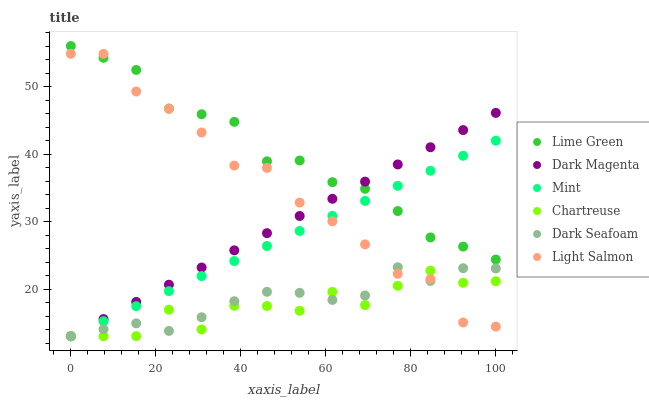Does Chartreuse have the minimum area under the curve?
Answer yes or no. Yes. Does Lime Green have the maximum area under the curve?
Answer yes or no. Yes. Does Dark Magenta have the minimum area under the curve?
Answer yes or no. No. Does Dark Magenta have the maximum area under the curve?
Answer yes or no. No. Is Mint the smoothest?
Answer yes or no. Yes. Is Chartreuse the roughest?
Answer yes or no. Yes. Is Dark Magenta the smoothest?
Answer yes or no. No. Is Dark Magenta the roughest?
Answer yes or no. No. Does Dark Magenta have the lowest value?
Answer yes or no. Yes. Does Lime Green have the lowest value?
Answer yes or no. No. Does Lime Green have the highest value?
Answer yes or no. Yes. Does Dark Magenta have the highest value?
Answer yes or no. No. Is Dark Seafoam less than Lime Green?
Answer yes or no. Yes. Is Lime Green greater than Chartreuse?
Answer yes or no. Yes. Does Light Salmon intersect Mint?
Answer yes or no. Yes. Is Light Salmon less than Mint?
Answer yes or no. No. Is Light Salmon greater than Mint?
Answer yes or no. No. Does Dark Seafoam intersect Lime Green?
Answer yes or no. No. 